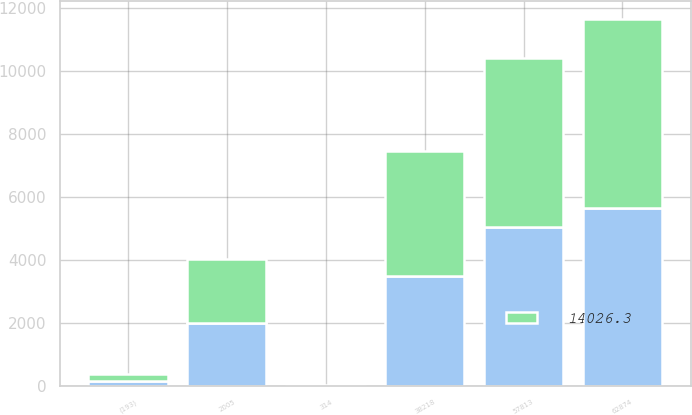Convert chart to OTSL. <chart><loc_0><loc_0><loc_500><loc_500><stacked_bar_chart><ecel><fcel>2005<fcel>62874<fcel>57813<fcel>38218<fcel>314<fcel>(193)<nl><fcel>14026.3<fcel>2004<fcel>5975.1<fcel>5343<fcel>3957.9<fcel>24.3<fcel>217.1<nl><fcel>nan<fcel>2003<fcel>5652.9<fcel>5046.7<fcel>3477.7<fcel>3.7<fcel>154.7<nl></chart> 